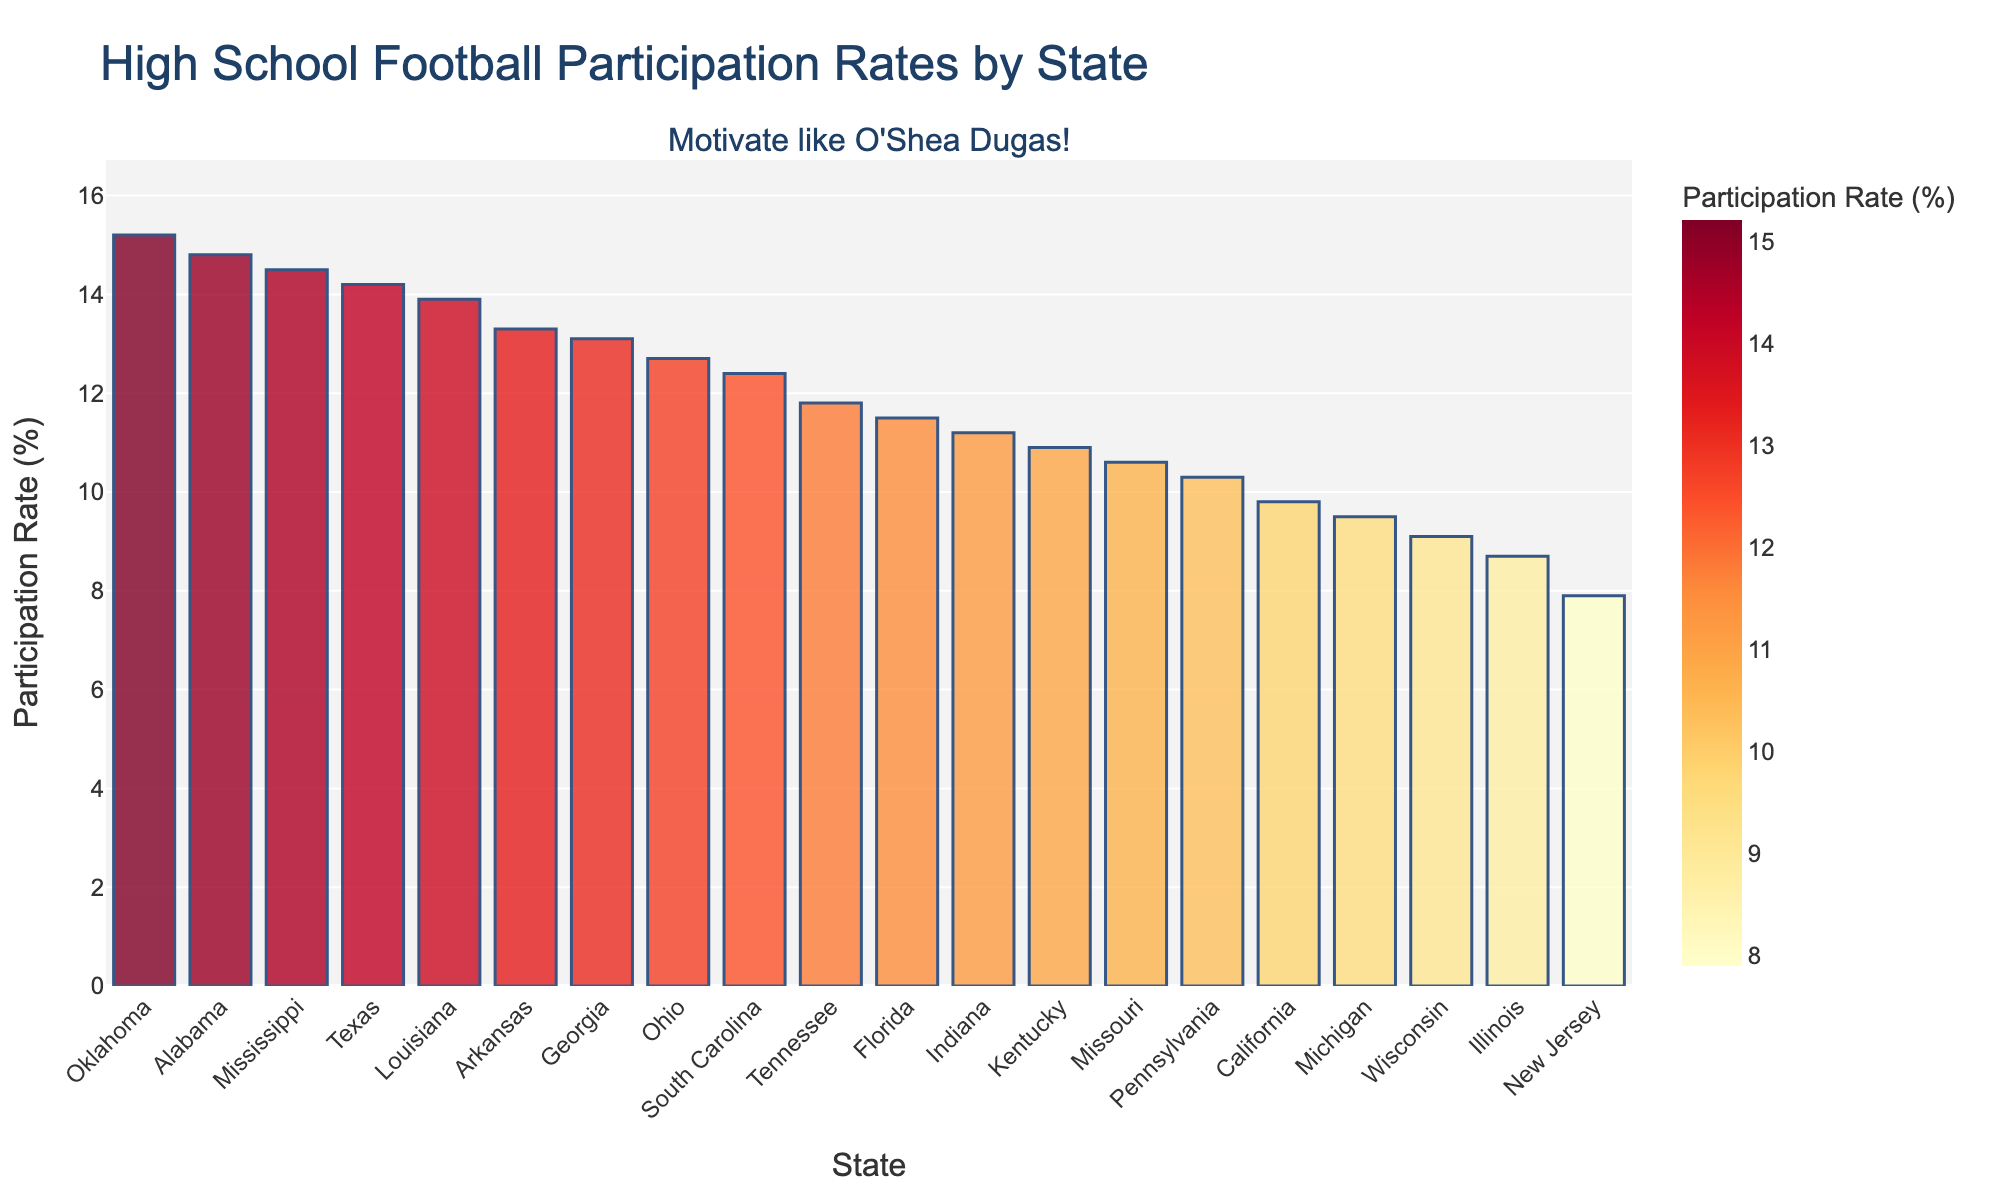Which state has the highest high school football participation rate? The highest bar in the chart indicates the state with the highest participation rate. In the chart, Oklahoma has the highest bar.
Answer: Oklahoma Which state has the lowest high school football participation rate? The lowest bar in the chart indicates the state with the lowest participation rate. In the chart, New Jersey has the lowest bar.
Answer: New Jersey How does the participation rate in Texas compare to that of California? To compare the rates, observe the heights of the bars for both states. Texas has a higher participation rate at 14.2% compared to California's 9.8%.
Answer: Texas has a higher rate What is the total participation rate for Alabama, Mississippi, and Arkansas combined? Add the participation rates for the three states. Alabama is 14.8%, Mississippi is 14.5%, and Arkansas is 13.3%. 14.8 + 14.5 + 13.3 = 42.6
Answer: 42.6% Which states have a participation rate above 12%? Identify the bars that exceed the 12% mark. The states are Texas, Alabama, Georgia, Oklahoma, Louisiana, Ohio, and Mississippi.
Answer: Texas, Alabama, Georgia, Oklahoma, Louisiana, Ohio, Mississippi What is the average participation rate for the states listed in the chart? Sum all participation rates and divide by the number of states. (14.2 + 9.8 + 11.5 + 12.7 + 13.1 + 10.3 + 14.8 + 13.9 + 9.5 + 11.8 + 8.7 + 7.9 + 15.2 + 12.4 + 14.5 + 13.3 + 10.9 + 11.2 + 10.6 + 9.1) / 20 = 12.006
Answer: 12.0% Is the participation rate in South Carolina closer to that of Ohio or Tennessee? South Carolina's rate is 12.4%, Ohio's rate is 12.7%, and Tennessee's rate is 11.8%. The difference between South Carolina and Ohio is 0.3%; the difference with Tennessee is 0.6%.
Answer: Ohio Which state has the third highest participation rate? Rank the states by their bar heights and identify the third tallest bar. The third highest participation rate is in Alabama.
Answer: Alabama What's the difference in participation rates between Missouri and Indiana? Subtract the participation rate of Indiana (11.2%) from Missouri (10.6%). 11.2 - 10.6 = 0.6
Answer: 0.6 How do the colors of the bars change with participation rates? Observe the color gradient used in the chart. Bars with higher participation rates are darker/shaded towards red, while lower rates are lighter/yellowish in color.
Answer: Darker colors indicate higher rates 